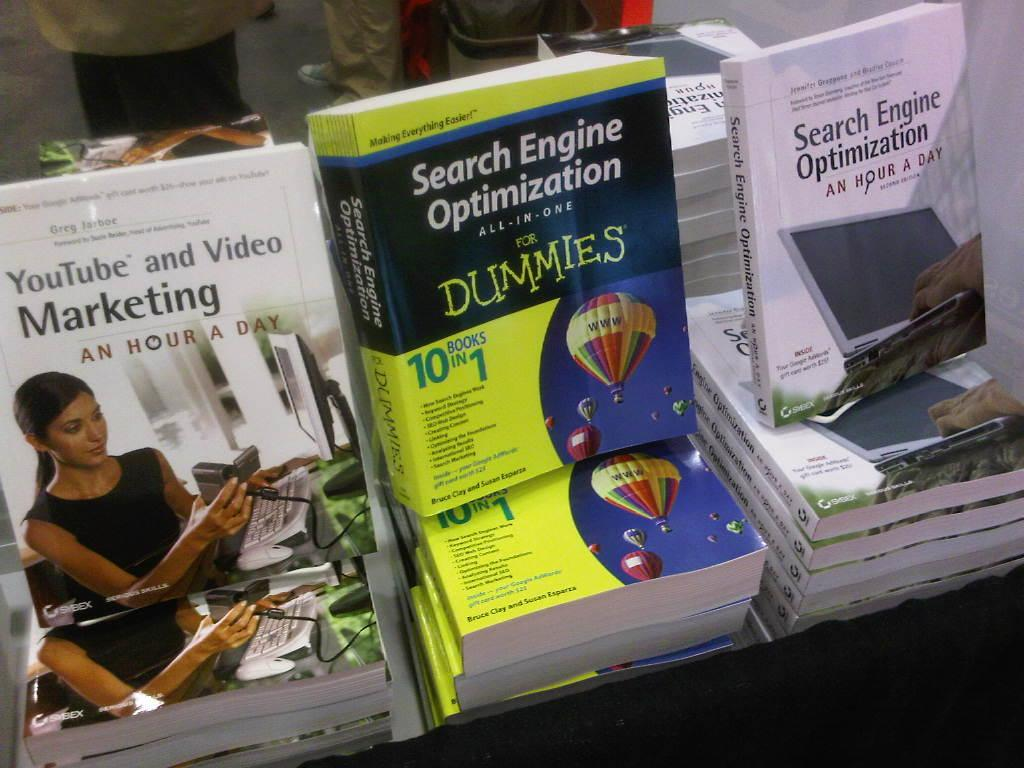<image>
Relay a brief, clear account of the picture shown. A search engine optimization book for dummies displayed between other web developement books. 